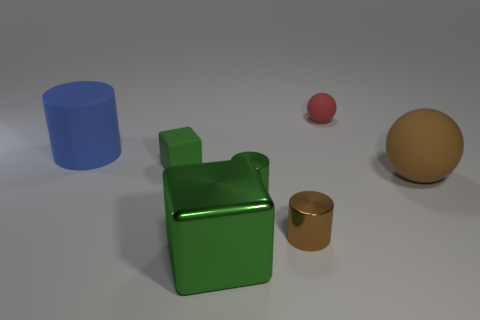Taking into account the shadows, what can you discern about the light source in this scene? Observing the direction and length of the shadows cast by the objects, it is apparent that the light source is situated to the top left of the scene. The shadows are relatively soft, which suggests that the light source may be diffused, possibly from an overhead diffuser, or a soft-box used in a photography studio setup. 